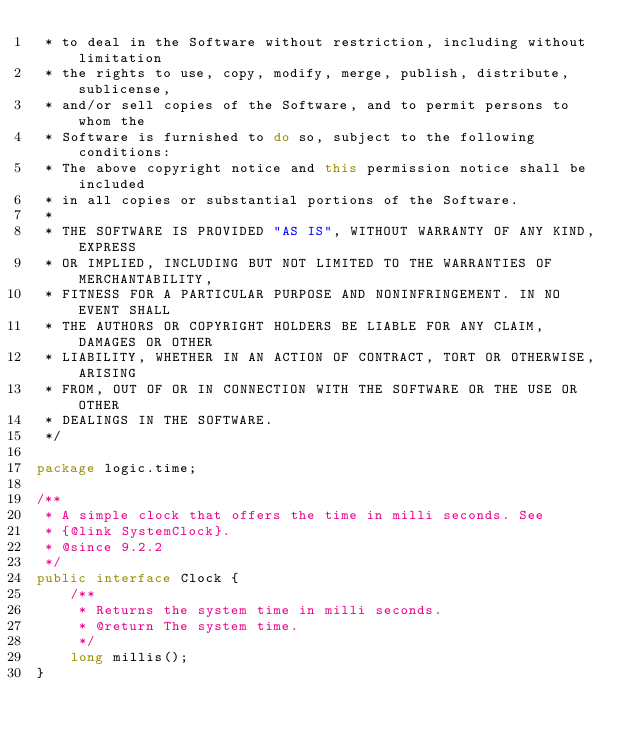<code> <loc_0><loc_0><loc_500><loc_500><_Java_> * to deal in the Software without restriction, including without limitation
 * the rights to use, copy, modify, merge, publish, distribute, sublicense,
 * and/or sell copies of the Software, and to permit persons to whom the
 * Software is furnished to do so, subject to the following conditions:
 * The above copyright notice and this permission notice shall be included
 * in all copies or substantial portions of the Software.
 *
 * THE SOFTWARE IS PROVIDED "AS IS", WITHOUT WARRANTY OF ANY KIND, EXPRESS
 * OR IMPLIED, INCLUDING BUT NOT LIMITED TO THE WARRANTIES OF MERCHANTABILITY,
 * FITNESS FOR A PARTICULAR PURPOSE AND NONINFRINGEMENT. IN NO EVENT SHALL
 * THE AUTHORS OR COPYRIGHT HOLDERS BE LIABLE FOR ANY CLAIM, DAMAGES OR OTHER
 * LIABILITY, WHETHER IN AN ACTION OF CONTRACT, TORT OR OTHERWISE, ARISING
 * FROM, OUT OF OR IN CONNECTION WITH THE SOFTWARE OR THE USE OR OTHER
 * DEALINGS IN THE SOFTWARE.
 */

package logic.time;

/**
 * A simple clock that offers the time in milli seconds. See
 * {@link SystemClock}.
 * @since 9.2.2
 */
public interface Clock {
    /**
     * Returns the system time in milli seconds.
     * @return The system time.
     */
    long millis();
}
</code> 